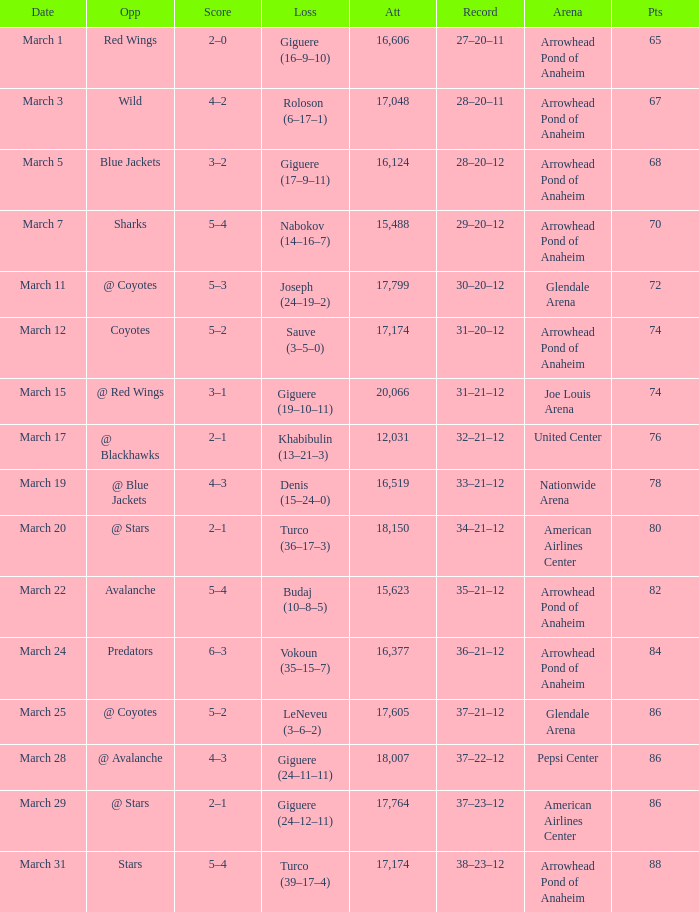What is the Record of the game with an Attendance of more than 16,124 and a Score of 6–3? 36–21–12. 